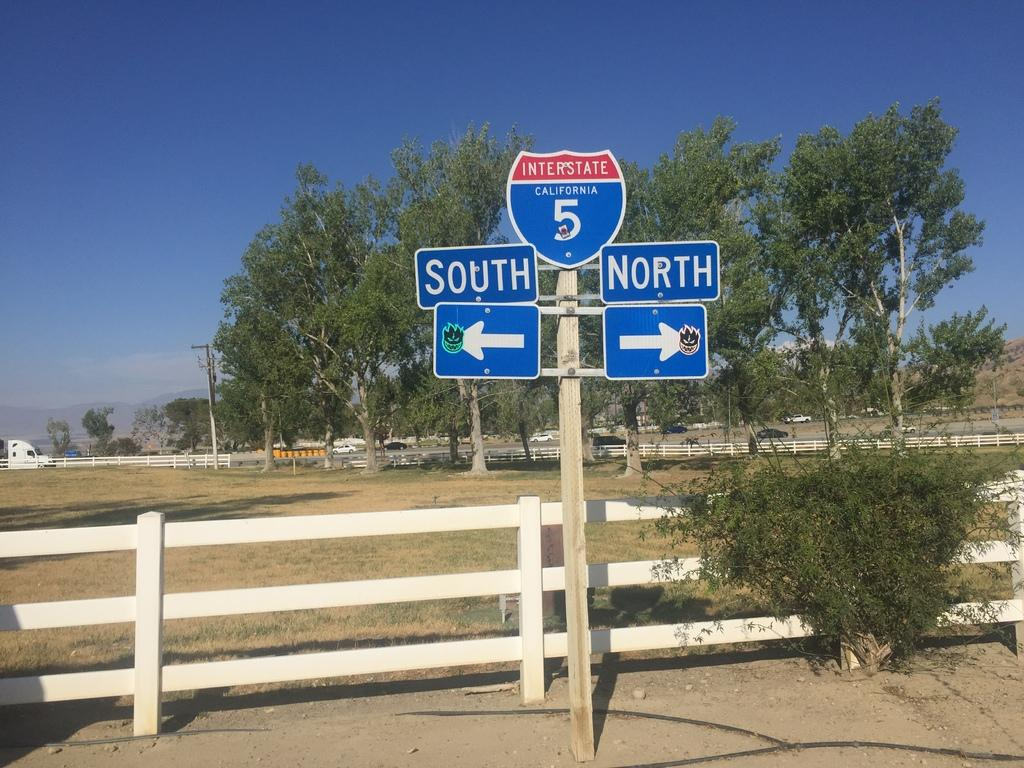Provide a one-sentence caption for the provided image. Directional road sign for Interstate 5 in California. 